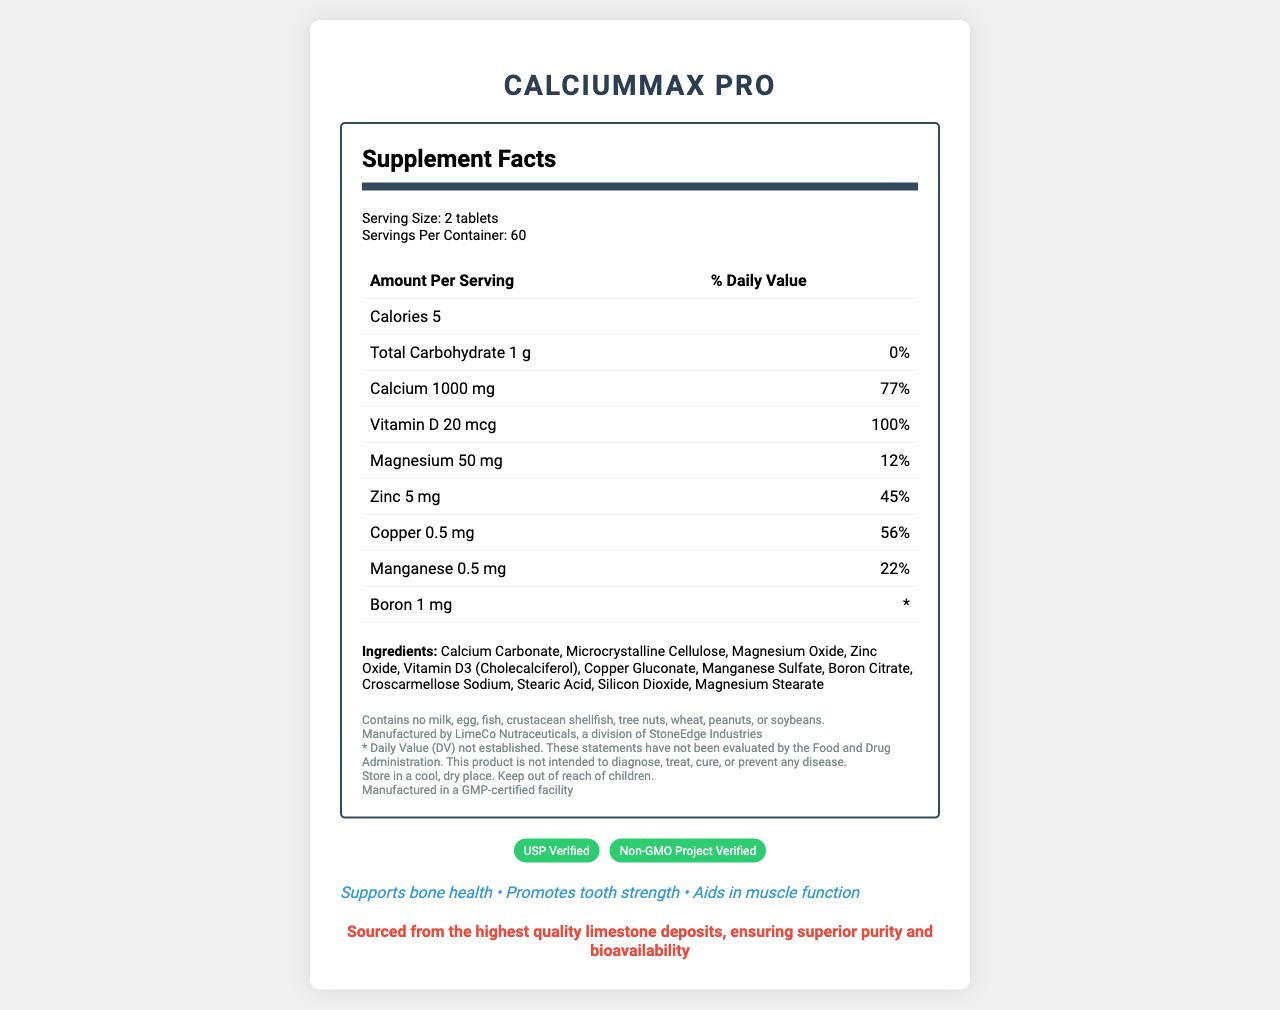Who manufactures CalciumMax Pro? The manufacturer information is listed in the disclaimer section of the document.
Answer: LimeCo Nutraceuticals, a division of StoneEdge Industries What is the percentage of Daily Value for calcium in CalciumMax Pro? The document states that each serving provides 1000 mg of calcium, which is 77% of the Daily Value.
Answer: 77% How many servings are there per container of CalciumMax Pro? The serving information section mentions that each container holds 60 servings.
Answer: 60 servings Does CalciumMax Pro contain any allergens such as milk or peanuts? The allergen information clearly states that the product contains no milk, egg, fish, crustacean shellfish, tree nuts, wheat, peanuts, or soybeans.
Answer: No What is the serving size of CalciumMax Pro? Under the serving information section, it is stated that a serving size is 2 tablets.
Answer: 2 tablets Which ingredient is listed first in CalciumMax Pro? A. Microcrystalline Cellulose B. Calcium Carbonate C. Magnesium Oxide D. Cholecalciferol Ingredients are often listed in order of quantity, and Calcium Carbonate is listed as the first ingredient.
Answer: B. Calcium Carbonate What is the percentage of Daily Value for Vitamin D in CalciumMax Pro? The document specifies that each serving provides 20 mcg of Vitamin D, which is 100% of the Daily Value.
Answer: 100% Which certification does CalciumMax Pro have? A. Non-GMO B. Gluten-Free C. Organic D. Vegan The certifications listed on the document include "Non-GMO Project Verified".
Answer: A. Non-GMO True or False: CalciumMax Pro is intended to diagnose, treat, cure, or prevent any disease. The disclaimer section explicitly states that the product is not intended to diagnose, treat, cure, or prevent any disease.
Answer: False For what health benefits is CalciumMax Pro marketed? The marketing claims section lists these specific health benefits.
Answer: Supports bone health, promotes tooth strength, aids in muscle function Describe the main idea of the document. The document's main purpose is to inform consumers about the nutritional facts and benefits of the CalciumMax Pro supplement, as well as provide assurances regarding quality and safety.
Answer: The document provides detailed nutritional information for the dietary supplement CalciumMax Pro, including serving size, nutritional content, ingredients, allergen information, manufacturer details, certifications, marketing claims, and storage suggestions. How much boron is in each serving of CalciumMax Pro? The document lists that each serving contains 1 mg of boron.
Answer: 1 mg What is the combined Daily Value percentage for magnesium and zinc in a serving of CalciumMax Pro? Magnesium has a 12% Daily Value, and zinc has a 45% Daily Value. Adding these together gives 57%.
Answer: 57% What is unique about the sourcing of the calcium in CalciumMax Pro? The competitive advantage section highlights the superior sourcing of the calcium used in the product.
Answer: Sourced from the highest quality limestone deposits, ensuring superior purity and bioavailability How many calories are there per serving of CalciumMax Pro? A. 5 B. 10 C. 20 D. 1 The document specifies that there are 5 calories per serving.
Answer: A. 5 What is the chemical form of Vitamin D listed in CalciumMax Pro's ingredients? The ingredients section lists Vitamin D3 (Cholecalciferol) as the form of Vitamin D used in the supplement.
Answer: Cholecalciferol (Vitamin D3) What is the storage suggestion for CalciumMax Pro? The storage suggestions section provides this specific instruction.
Answer: Store in a cool, dry place. Keep out of reach of children. Does CalciumMax Pro contain silicon dioxide? Silicon Dioxide is listed as one of the ingredients in CalciumMax Pro.
Answer: Yes What is the Daily Value percentage for copper in CalciumMax Pro? The document states that each serving provides 0.5 mg of copper, which is 56% of the Daily Value.
Answer: 56% How many types of certifications are listed for CalciumMax Pro? The document mentions two certifications: USP Verified and Non-GMO Project Verified.
Answer: Two What is the country of origin for CalciumMax Pro? The document does not provide any information about the country of origin for the product.
Answer: Not enough information 